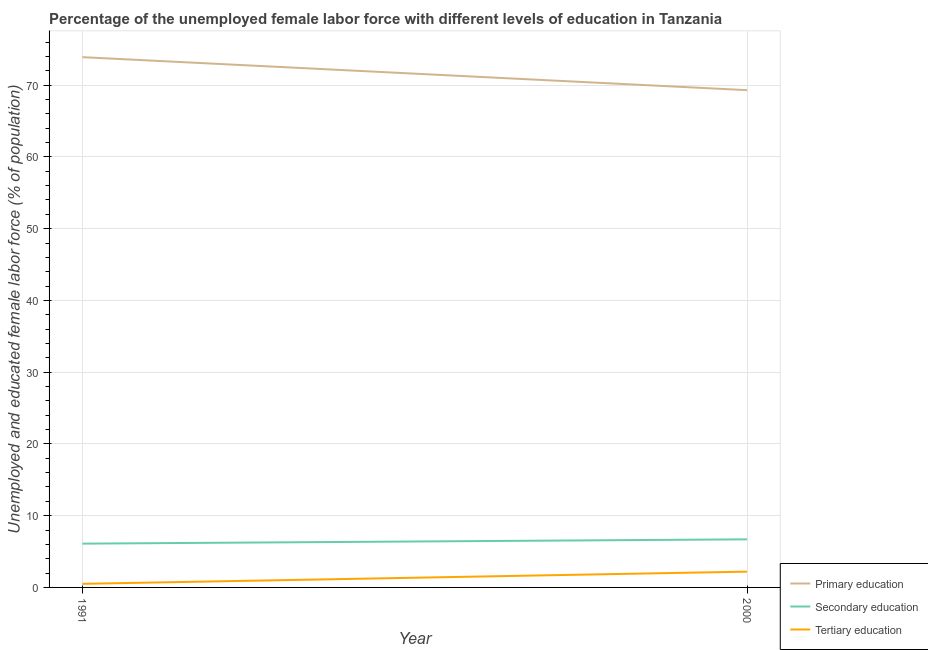How many different coloured lines are there?
Offer a very short reply. 3. What is the percentage of female labor force who received tertiary education in 1991?
Give a very brief answer. 0.5. Across all years, what is the maximum percentage of female labor force who received tertiary education?
Your answer should be very brief. 2.2. Across all years, what is the minimum percentage of female labor force who received primary education?
Your answer should be very brief. 69.3. What is the total percentage of female labor force who received primary education in the graph?
Your answer should be compact. 143.2. What is the difference between the percentage of female labor force who received secondary education in 1991 and that in 2000?
Give a very brief answer. -0.6. What is the difference between the percentage of female labor force who received secondary education in 1991 and the percentage of female labor force who received primary education in 2000?
Your answer should be compact. -63.2. What is the average percentage of female labor force who received secondary education per year?
Make the answer very short. 6.4. In the year 1991, what is the difference between the percentage of female labor force who received primary education and percentage of female labor force who received tertiary education?
Give a very brief answer. 73.4. In how many years, is the percentage of female labor force who received primary education greater than 40 %?
Provide a short and direct response. 2. What is the ratio of the percentage of female labor force who received tertiary education in 1991 to that in 2000?
Your answer should be compact. 0.23. Is the percentage of female labor force who received secondary education in 1991 less than that in 2000?
Your answer should be very brief. Yes. Is it the case that in every year, the sum of the percentage of female labor force who received primary education and percentage of female labor force who received secondary education is greater than the percentage of female labor force who received tertiary education?
Your answer should be very brief. Yes. Does the percentage of female labor force who received tertiary education monotonically increase over the years?
Your response must be concise. Yes. Is the percentage of female labor force who received primary education strictly greater than the percentage of female labor force who received tertiary education over the years?
Give a very brief answer. Yes. Is the percentage of female labor force who received primary education strictly less than the percentage of female labor force who received tertiary education over the years?
Your answer should be very brief. No. How many years are there in the graph?
Your answer should be compact. 2. Are the values on the major ticks of Y-axis written in scientific E-notation?
Provide a succinct answer. No. Does the graph contain grids?
Your response must be concise. Yes. Where does the legend appear in the graph?
Make the answer very short. Bottom right. How are the legend labels stacked?
Make the answer very short. Vertical. What is the title of the graph?
Give a very brief answer. Percentage of the unemployed female labor force with different levels of education in Tanzania. What is the label or title of the X-axis?
Give a very brief answer. Year. What is the label or title of the Y-axis?
Provide a succinct answer. Unemployed and educated female labor force (% of population). What is the Unemployed and educated female labor force (% of population) in Primary education in 1991?
Provide a succinct answer. 73.9. What is the Unemployed and educated female labor force (% of population) in Secondary education in 1991?
Your answer should be compact. 6.1. What is the Unemployed and educated female labor force (% of population) in Tertiary education in 1991?
Your answer should be compact. 0.5. What is the Unemployed and educated female labor force (% of population) in Primary education in 2000?
Offer a very short reply. 69.3. What is the Unemployed and educated female labor force (% of population) of Secondary education in 2000?
Keep it short and to the point. 6.7. What is the Unemployed and educated female labor force (% of population) in Tertiary education in 2000?
Ensure brevity in your answer.  2.2. Across all years, what is the maximum Unemployed and educated female labor force (% of population) in Primary education?
Keep it short and to the point. 73.9. Across all years, what is the maximum Unemployed and educated female labor force (% of population) of Secondary education?
Offer a terse response. 6.7. Across all years, what is the maximum Unemployed and educated female labor force (% of population) of Tertiary education?
Your response must be concise. 2.2. Across all years, what is the minimum Unemployed and educated female labor force (% of population) of Primary education?
Offer a terse response. 69.3. Across all years, what is the minimum Unemployed and educated female labor force (% of population) of Secondary education?
Ensure brevity in your answer.  6.1. Across all years, what is the minimum Unemployed and educated female labor force (% of population) in Tertiary education?
Your response must be concise. 0.5. What is the total Unemployed and educated female labor force (% of population) of Primary education in the graph?
Offer a terse response. 143.2. What is the total Unemployed and educated female labor force (% of population) of Secondary education in the graph?
Make the answer very short. 12.8. What is the total Unemployed and educated female labor force (% of population) in Tertiary education in the graph?
Offer a terse response. 2.7. What is the difference between the Unemployed and educated female labor force (% of population) of Primary education in 1991 and the Unemployed and educated female labor force (% of population) of Secondary education in 2000?
Ensure brevity in your answer.  67.2. What is the difference between the Unemployed and educated female labor force (% of population) in Primary education in 1991 and the Unemployed and educated female labor force (% of population) in Tertiary education in 2000?
Provide a short and direct response. 71.7. What is the average Unemployed and educated female labor force (% of population) of Primary education per year?
Make the answer very short. 71.6. What is the average Unemployed and educated female labor force (% of population) of Secondary education per year?
Offer a very short reply. 6.4. What is the average Unemployed and educated female labor force (% of population) in Tertiary education per year?
Make the answer very short. 1.35. In the year 1991, what is the difference between the Unemployed and educated female labor force (% of population) in Primary education and Unemployed and educated female labor force (% of population) in Secondary education?
Provide a short and direct response. 67.8. In the year 1991, what is the difference between the Unemployed and educated female labor force (% of population) of Primary education and Unemployed and educated female labor force (% of population) of Tertiary education?
Provide a short and direct response. 73.4. In the year 1991, what is the difference between the Unemployed and educated female labor force (% of population) of Secondary education and Unemployed and educated female labor force (% of population) of Tertiary education?
Give a very brief answer. 5.6. In the year 2000, what is the difference between the Unemployed and educated female labor force (% of population) of Primary education and Unemployed and educated female labor force (% of population) of Secondary education?
Give a very brief answer. 62.6. In the year 2000, what is the difference between the Unemployed and educated female labor force (% of population) in Primary education and Unemployed and educated female labor force (% of population) in Tertiary education?
Offer a very short reply. 67.1. What is the ratio of the Unemployed and educated female labor force (% of population) in Primary education in 1991 to that in 2000?
Your answer should be compact. 1.07. What is the ratio of the Unemployed and educated female labor force (% of population) in Secondary education in 1991 to that in 2000?
Ensure brevity in your answer.  0.91. What is the ratio of the Unemployed and educated female labor force (% of population) of Tertiary education in 1991 to that in 2000?
Provide a short and direct response. 0.23. What is the difference between the highest and the second highest Unemployed and educated female labor force (% of population) of Primary education?
Provide a short and direct response. 4.6. What is the difference between the highest and the second highest Unemployed and educated female labor force (% of population) of Tertiary education?
Give a very brief answer. 1.7. What is the difference between the highest and the lowest Unemployed and educated female labor force (% of population) of Primary education?
Your response must be concise. 4.6. What is the difference between the highest and the lowest Unemployed and educated female labor force (% of population) in Secondary education?
Offer a terse response. 0.6. 